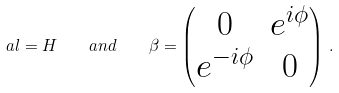<formula> <loc_0><loc_0><loc_500><loc_500>\ a l = H \quad a n d \quad \beta = \begin{pmatrix} 0 & e ^ { i \phi } \\ e ^ { - i \phi } & 0 \end{pmatrix} \, .</formula> 